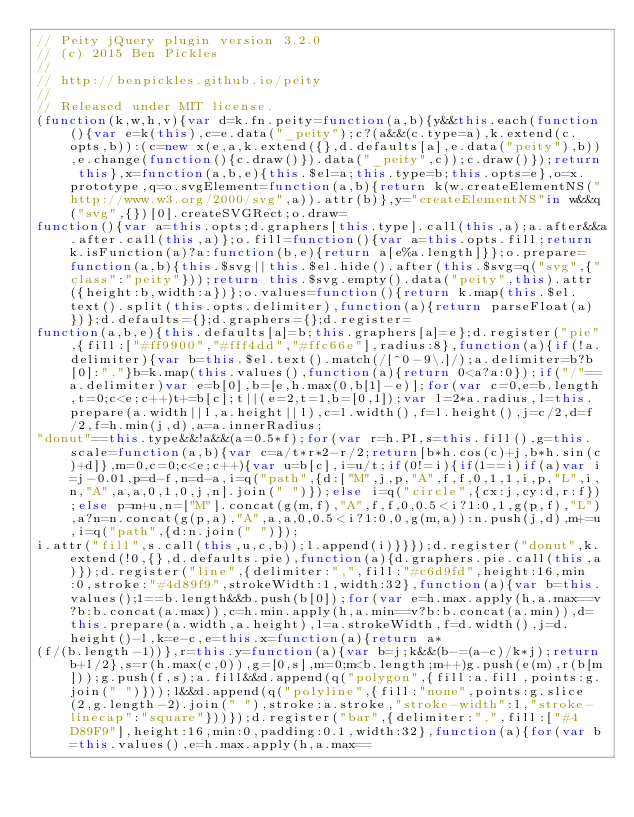Convert code to text. <code><loc_0><loc_0><loc_500><loc_500><_JavaScript_>// Peity jQuery plugin version 3.2.0
// (c) 2015 Ben Pickles
//
// http://benpickles.github.io/peity
//
// Released under MIT license.
(function(k,w,h,v){var d=k.fn.peity=function(a,b){y&&this.each(function(){var e=k(this),c=e.data("_peity");c?(a&&(c.type=a),k.extend(c.opts,b)):(c=new x(e,a,k.extend({},d.defaults[a],e.data("peity"),b)),e.change(function(){c.draw()}).data("_peity",c));c.draw()});return this},x=function(a,b,e){this.$el=a;this.type=b;this.opts=e},o=x.prototype,q=o.svgElement=function(a,b){return k(w.createElementNS("http://www.w3.org/2000/svg",a)).attr(b)},y="createElementNS"in w&&q("svg",{})[0].createSVGRect;o.draw=
function(){var a=this.opts;d.graphers[this.type].call(this,a);a.after&&a.after.call(this,a)};o.fill=function(){var a=this.opts.fill;return k.isFunction(a)?a:function(b,e){return a[e%a.length]}};o.prepare=function(a,b){this.$svg||this.$el.hide().after(this.$svg=q("svg",{"class":"peity"}));return this.$svg.empty().data("peity",this).attr({height:b,width:a})};o.values=function(){return k.map(this.$el.text().split(this.opts.delimiter),function(a){return parseFloat(a)})};d.defaults={};d.graphers={};d.register=
function(a,b,e){this.defaults[a]=b;this.graphers[a]=e};d.register("pie",{fill:["#ff9900","#fff4dd","#ffc66e"],radius:8},function(a){if(!a.delimiter){var b=this.$el.text().match(/[^0-9\.]/);a.delimiter=b?b[0]:","}b=k.map(this.values(),function(a){return 0<a?a:0});if("/"==a.delimiter)var e=b[0],b=[e,h.max(0,b[1]-e)];for(var c=0,e=b.length,t=0;c<e;c++)t+=b[c];t||(e=2,t=1,b=[0,1]);var l=2*a.radius,l=this.prepare(a.width||l,a.height||l),c=l.width(),f=l.height(),j=c/2,d=f/2,f=h.min(j,d),a=a.innerRadius;
"donut"==this.type&&!a&&(a=0.5*f);for(var r=h.PI,s=this.fill(),g=this.scale=function(a,b){var c=a/t*r*2-r/2;return[b*h.cos(c)+j,b*h.sin(c)+d]},m=0,c=0;c<e;c++){var u=b[c],i=u/t;if(0!=i){if(1==i)if(a)var i=j-0.01,p=d-f,n=d-a,i=q("path",{d:["M",j,p,"A",f,f,0,1,1,i,p,"L",i,n,"A",a,a,0,1,0,j,n].join(" ")});else i=q("circle",{cx:j,cy:d,r:f});else p=m+u,n=["M"].concat(g(m,f),"A",f,f,0,0.5<i?1:0,1,g(p,f),"L"),a?n=n.concat(g(p,a),"A",a,a,0,0.5<i?1:0,0,g(m,a)):n.push(j,d),m+=u,i=q("path",{d:n.join(" ")});
i.attr("fill",s.call(this,u,c,b));l.append(i)}}});d.register("donut",k.extend(!0,{},d.defaults.pie),function(a){d.graphers.pie.call(this,a)});d.register("line",{delimiter:",",fill:"#c6d9fd",height:16,min:0,stroke:"#4d89f9",strokeWidth:1,width:32},function(a){var b=this.values();1==b.length&&b.push(b[0]);for(var e=h.max.apply(h,a.max==v?b:b.concat(a.max)),c=h.min.apply(h,a.min==v?b:b.concat(a.min)),d=this.prepare(a.width,a.height),l=a.strokeWidth,f=d.width(),j=d.height()-l,k=e-c,e=this.x=function(a){return a*
(f/(b.length-1))},r=this.y=function(a){var b=j;k&&(b-=(a-c)/k*j);return b+l/2},s=r(h.max(c,0)),g=[0,s],m=0;m<b.length;m++)g.push(e(m),r(b[m]));g.push(f,s);a.fill&&d.append(q("polygon",{fill:a.fill,points:g.join(" ")}));l&&d.append(q("polyline",{fill:"none",points:g.slice(2,g.length-2).join(" "),stroke:a.stroke,"stroke-width":l,"stroke-linecap":"square"}))});d.register("bar",{delimiter:",",fill:["#4D89F9"],height:16,min:0,padding:0.1,width:32},function(a){for(var b=this.values(),e=h.max.apply(h,a.max==</code> 